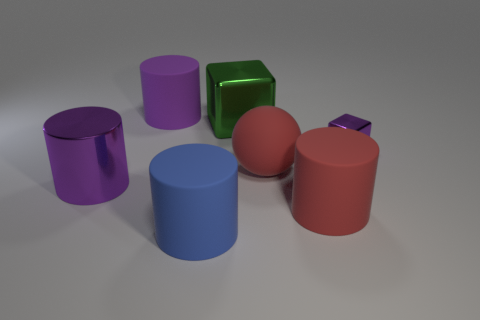Subtract all gray cylinders. Subtract all brown blocks. How many cylinders are left? 4 Add 2 big green blocks. How many objects exist? 9 Subtract all cubes. How many objects are left? 5 Add 5 purple rubber blocks. How many purple rubber blocks exist? 5 Subtract 0 purple balls. How many objects are left? 7 Subtract all balls. Subtract all cylinders. How many objects are left? 2 Add 1 purple objects. How many purple objects are left? 4 